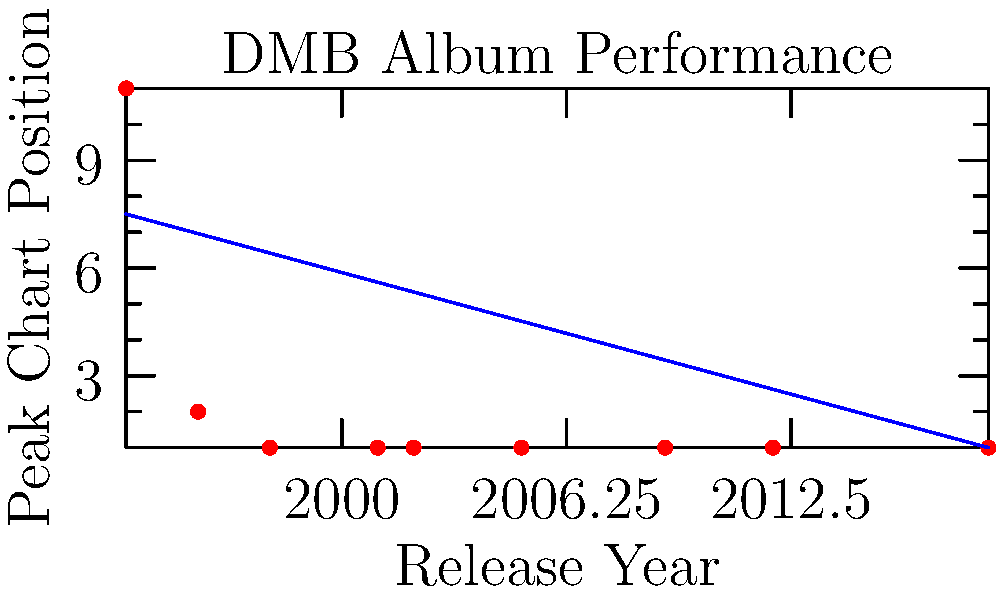Based on the scatter plot showing Dave Matthews Band's album release dates and their peak chart positions, what trend can be observed in the band's commercial success over time? To answer this question, we need to analyze the scatter plot:

1. The x-axis represents the album release years, ranging from 1994 to 2018.
2. The y-axis represents the peak chart positions, with 1 being the highest (best) position.
3. Each red dot represents an album, plotting its release year against its peak chart position.
4. The blue line is a trend line, showing the overall direction of the data.

Observations:
1. The first album in 1994 peaked at position 11.
2. The second album in 1996 reached position 2.
3. From 1998 onwards, all albums reached the number 1 position.
4. The trend line slopes downward from left to right, indicating an improvement in chart performance over time (remember, lower numbers are better for chart positions).

Given these observations, we can conclude that Dave Matthews Band's commercial success, as measured by peak chart positions, has improved over time. The band consistently achieved number 1 albums from 1998 onward, showing a trend of increasing commercial success and maintaining it at the highest level for most of their career.
Answer: Increasing commercial success over time, with consistent #1 albums from 1998 onward. 